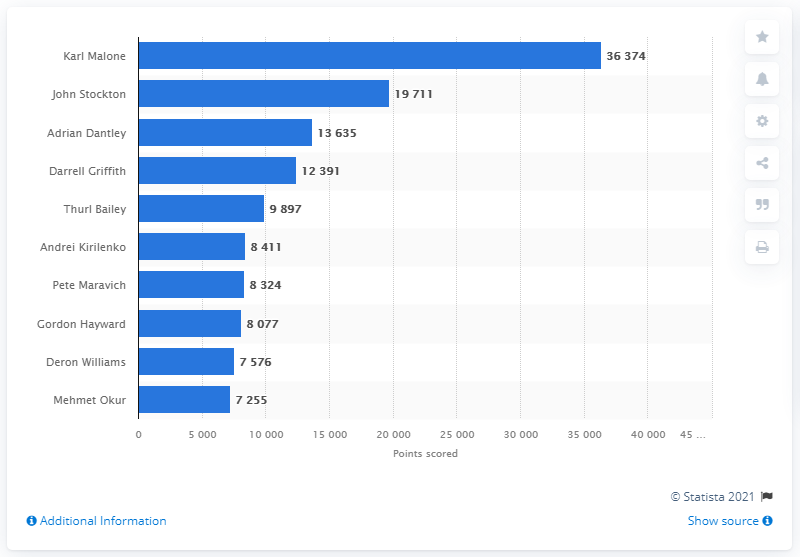Give some essential details in this illustration. Karl Malone is the career points leader of the Utah Jazz. 